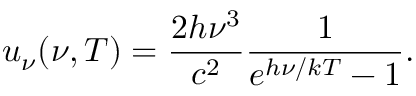Convert formula to latex. <formula><loc_0><loc_0><loc_500><loc_500>u _ { \nu } ( \nu , T ) = { \frac { 2 h \nu ^ { 3 } } { c ^ { 2 } } } { \frac { 1 } { e ^ { h \nu / k T } - 1 } } .</formula> 